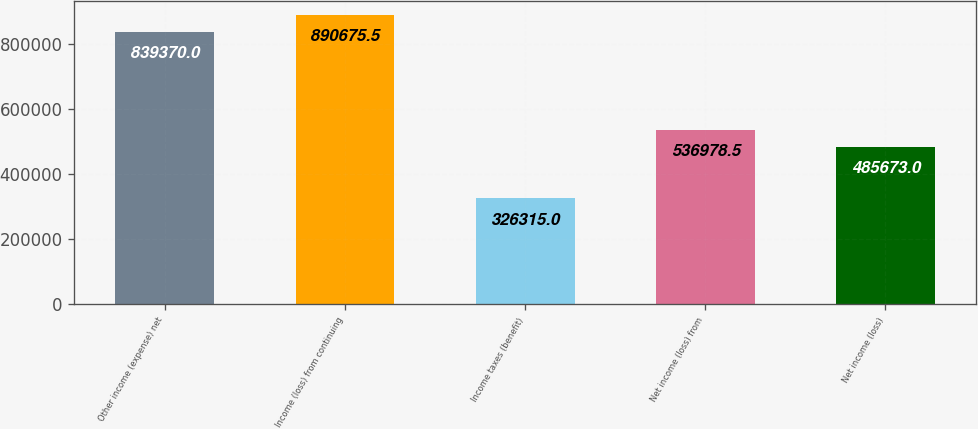<chart> <loc_0><loc_0><loc_500><loc_500><bar_chart><fcel>Other income (expense) net<fcel>Income (loss) from continuing<fcel>Income taxes (benefit)<fcel>Net income (loss) from<fcel>Net income (loss)<nl><fcel>839370<fcel>890676<fcel>326315<fcel>536978<fcel>485673<nl></chart> 